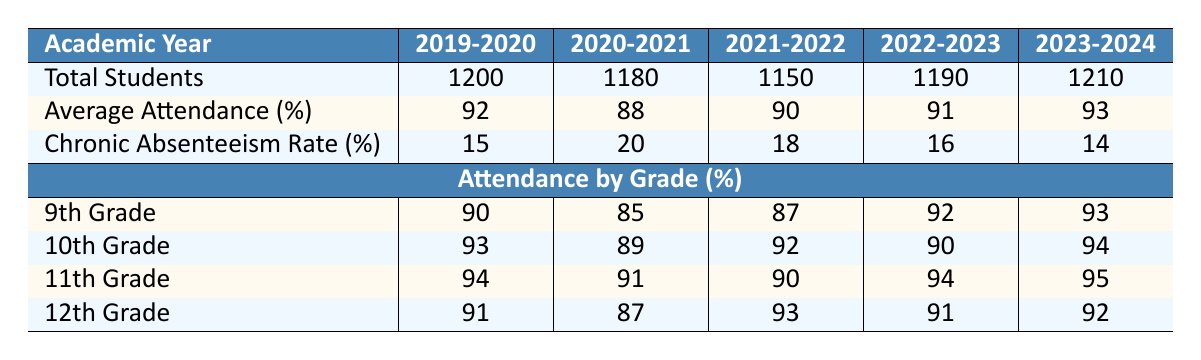What was the average attendance rate for Lincoln High School in 2022-2023? According to the table, the average attendance rate for Lincoln High School in the academic year 2022-2023 is listed directly in the row for Average Attendance, which shows 91%.
Answer: 91% What is the chronic absenteeism rate for Lincoln High School in 2020-2021? The table indicates that the chronic absenteeism rate for Lincoln High School in the academic year 2020-2021 is 20%, found in the row labeled Chronic Absenteeism Rate.
Answer: 20% Which grade had the highest attendance rate in the academic year 2023-2024? Looking at the Attendance by Grade section for the academic year 2023-2024, the 11th grade has the highest attendance rate at 95%, which is greater than the other grades.
Answer: 11th Grade What is the total number of students at Lincoln High School for all academic years from 2019-2020 to 2023-2024? To find the total number of students over the years, we add the values from the Total Students row: 1200 + 1180 + 1150 + 1190 + 1210 = 6130.
Answer: 6130 Did the average attendance rate increase or decrease from 2021-2022 to 2023-2024? The average attendance rate increased from 90% in 2021-2022 to 93% in 2023-2024, as noted in the Average Attendance row for those years, indicating an upward trend.
Answer: Increase Which grade had the lowest chronic absenteeism rate in the academic year 2023-2024? The table does not provide grade-specific chronic absenteeism rates, so we cannot directly determine which grade had the lowest in that year based on available data. However, the chronic absenteeism rate for the overall school was 14%.
Answer: Not Applicable What was the average attendance rate across all grades in 2019-2020? To calculate the average attendance for all grades in 2019-2020, we add the attendance rates for each grade: (90 + 93 + 94 + 91) / 4 = 91. The average attendance rate is therefore 91%.
Answer: 91% Was the chronic absenteeism rate lower in 2023-2024 than in 2019-2020? Comparing the two rates, the chronic absenteeism rate in 2023-2024 is 14%, while in 2019-2020 it was 15%. Since 14% is less than 15%, the rate was lower in 2023-2024.
Answer: Yes Which academic year had the highest total number of students enrolled? The highest total number of students enrolled was in the academic year 2023-2024, with 1210 students, as indicated in the Total Students row for that year.
Answer: 2023-2024 